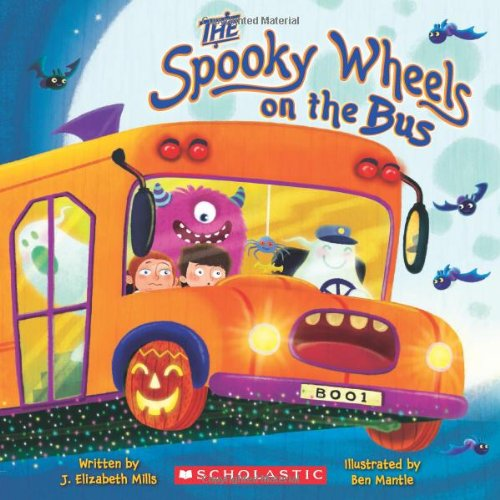What type of book is this? This is a children's book, specifically designed to engage young readers with fun, spooky themes and vibrant illustrations that capture the spirit of Halloween. 